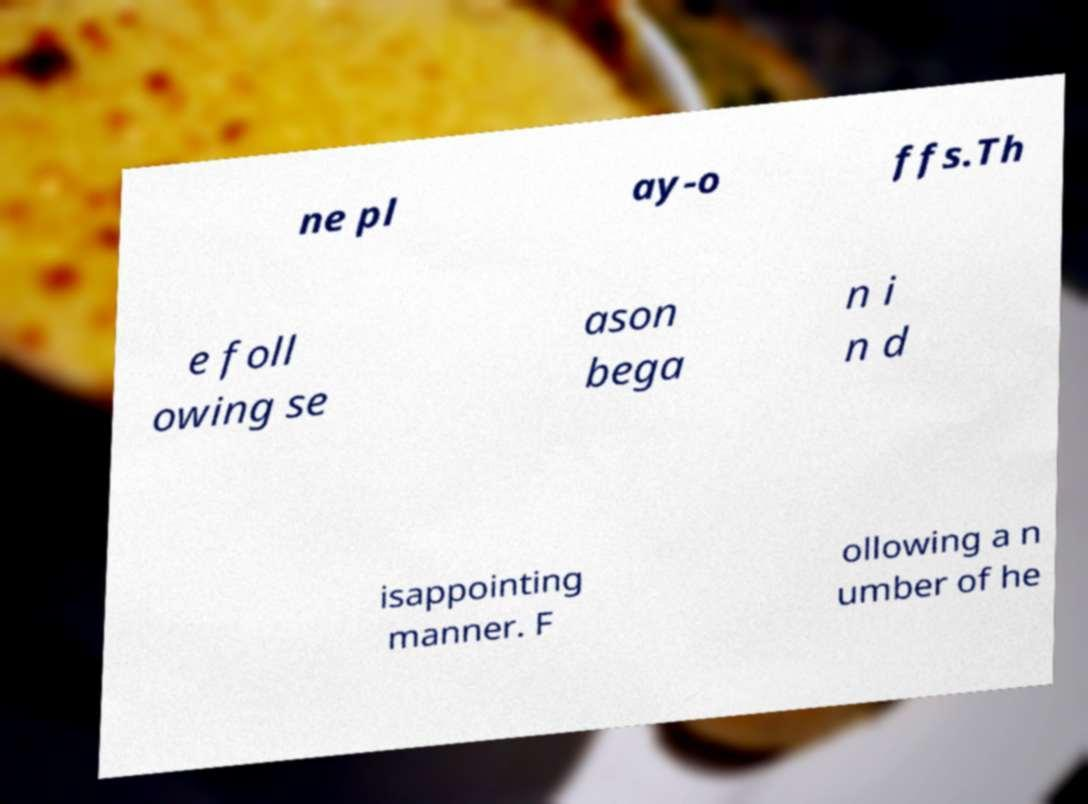For documentation purposes, I need the text within this image transcribed. Could you provide that? ne pl ay-o ffs.Th e foll owing se ason bega n i n d isappointing manner. F ollowing a n umber of he 